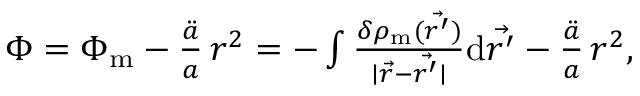Convert formula to latex. <formula><loc_0><loc_0><loc_500><loc_500>\begin{array} { r } { \Phi = \Phi _ { m } - \frac { \ddot { a } } { a } \, r ^ { 2 } = - \int \frac { \delta \rho _ { m } ( \vec { r ^ { \prime } } ) } { | \vec { r } - \vec { r ^ { \prime } } | } d \vec { r ^ { \prime } } - \frac { \ddot { a } } { a } \, r ^ { 2 } , } \end{array}</formula> 